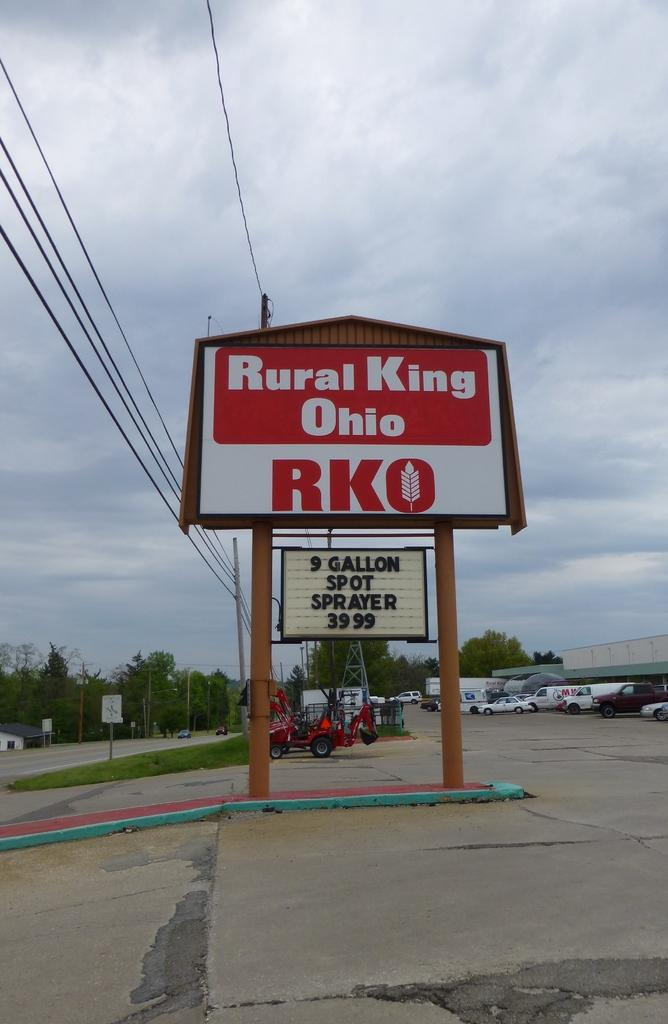<image>
Describe the image concisely. A Rural King Ohio sign advertising a spot sprayer.. 